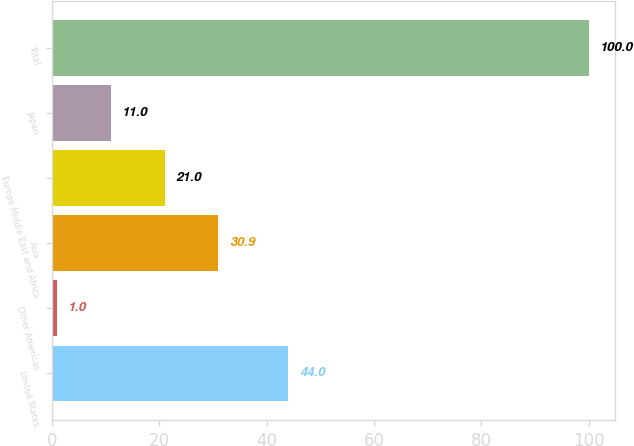<chart> <loc_0><loc_0><loc_500><loc_500><bar_chart><fcel>United States<fcel>Other Americas<fcel>Asia<fcel>Europe Middle East and Africa<fcel>Japan<fcel>Total<nl><fcel>44<fcel>1<fcel>30.9<fcel>21<fcel>11<fcel>100<nl></chart> 